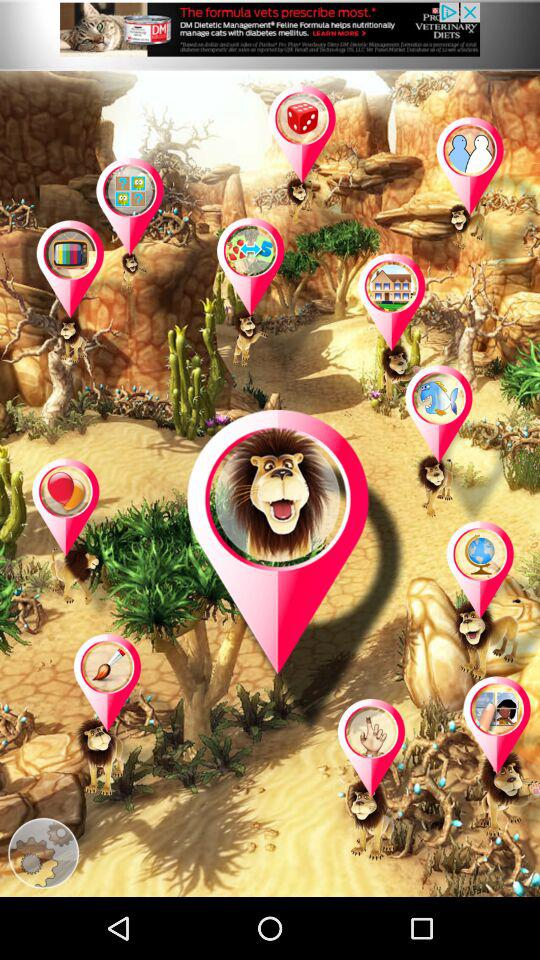How many pink pins have a picture of a lion on them?
Answer the question using a single word or phrase. 1 